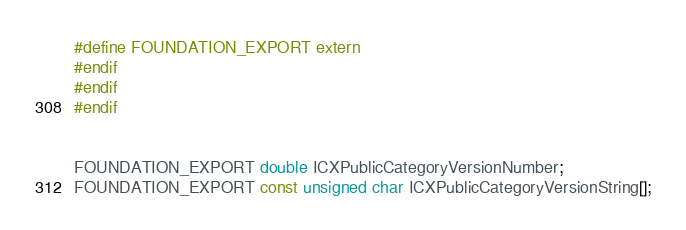Convert code to text. <code><loc_0><loc_0><loc_500><loc_500><_C_>#define FOUNDATION_EXPORT extern
#endif
#endif
#endif


FOUNDATION_EXPORT double ICXPublicCategoryVersionNumber;
FOUNDATION_EXPORT const unsigned char ICXPublicCategoryVersionString[];

</code> 